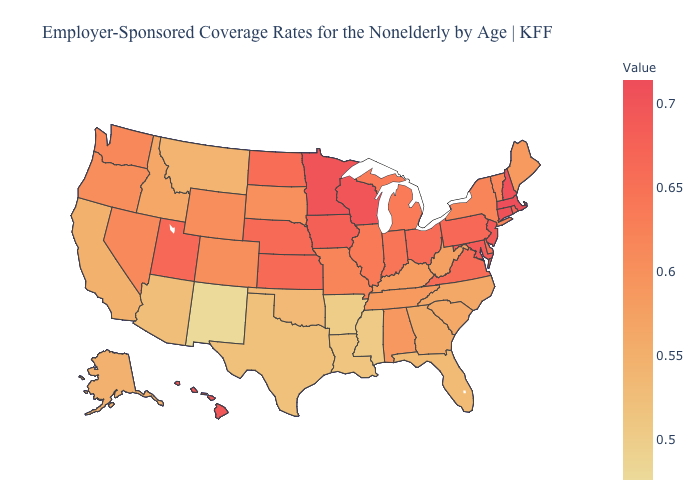Which states have the lowest value in the USA?
Answer briefly. New Mexico. Which states have the lowest value in the USA?
Short answer required. New Mexico. Does the map have missing data?
Answer briefly. No. Among the states that border California , which have the highest value?
Concise answer only. Nevada. Is the legend a continuous bar?
Give a very brief answer. Yes. Does Delaware have a lower value than New Mexico?
Concise answer only. No. 